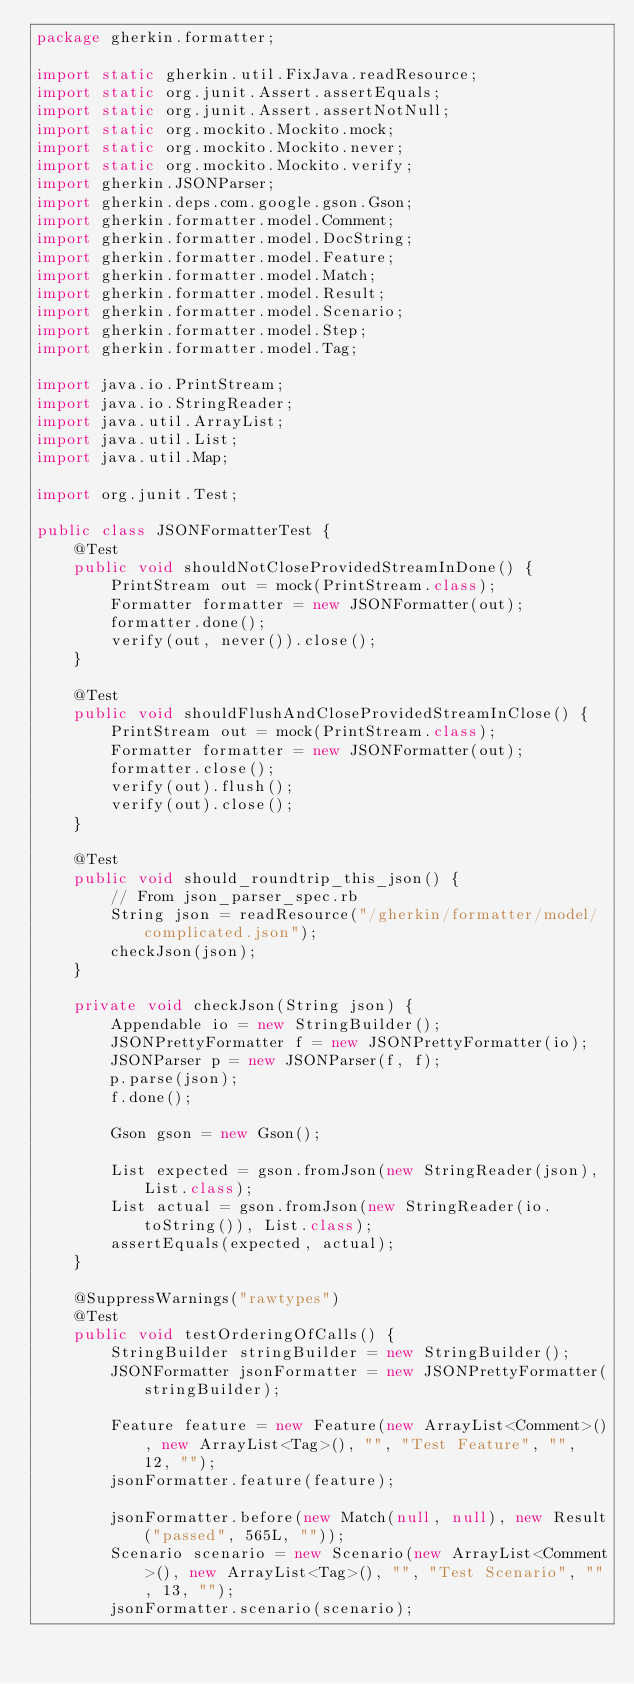<code> <loc_0><loc_0><loc_500><loc_500><_Java_>package gherkin.formatter;

import static gherkin.util.FixJava.readResource;
import static org.junit.Assert.assertEquals;
import static org.junit.Assert.assertNotNull;
import static org.mockito.Mockito.mock;
import static org.mockito.Mockito.never;
import static org.mockito.Mockito.verify;
import gherkin.JSONParser;
import gherkin.deps.com.google.gson.Gson;
import gherkin.formatter.model.Comment;
import gherkin.formatter.model.DocString;
import gherkin.formatter.model.Feature;
import gherkin.formatter.model.Match;
import gherkin.formatter.model.Result;
import gherkin.formatter.model.Scenario;
import gherkin.formatter.model.Step;
import gherkin.formatter.model.Tag;

import java.io.PrintStream;
import java.io.StringReader;
import java.util.ArrayList;
import java.util.List;
import java.util.Map;

import org.junit.Test;

public class JSONFormatterTest {
    @Test
    public void shouldNotCloseProvidedStreamInDone() {
        PrintStream out = mock(PrintStream.class);
        Formatter formatter = new JSONFormatter(out);
        formatter.done();
        verify(out, never()).close();
    }

    @Test
    public void shouldFlushAndCloseProvidedStreamInClose() {
        PrintStream out = mock(PrintStream.class);
        Formatter formatter = new JSONFormatter(out);
        formatter.close();
        verify(out).flush();
        verify(out).close();
    }

    @Test
    public void should_roundtrip_this_json() {
        // From json_parser_spec.rb
        String json = readResource("/gherkin/formatter/model/complicated.json");
        checkJson(json);
    }

    private void checkJson(String json) {
        Appendable io = new StringBuilder();
        JSONPrettyFormatter f = new JSONPrettyFormatter(io);
        JSONParser p = new JSONParser(f, f);
        p.parse(json);
        f.done();

        Gson gson = new Gson();

        List expected = gson.fromJson(new StringReader(json), List.class);
        List actual = gson.fromJson(new StringReader(io.toString()), List.class);
        assertEquals(expected, actual);
    }

    @SuppressWarnings("rawtypes")
    @Test
    public void testOrderingOfCalls() {
        StringBuilder stringBuilder = new StringBuilder();
        JSONFormatter jsonFormatter = new JSONPrettyFormatter(stringBuilder);

        Feature feature = new Feature(new ArrayList<Comment>(), new ArrayList<Tag>(), "", "Test Feature", "", 12, "");
        jsonFormatter.feature(feature);

        jsonFormatter.before(new Match(null, null), new Result("passed", 565L, ""));
        Scenario scenario = new Scenario(new ArrayList<Comment>(), new ArrayList<Tag>(), "", "Test Scenario", "", 13, "");
        jsonFormatter.scenario(scenario);
</code> 